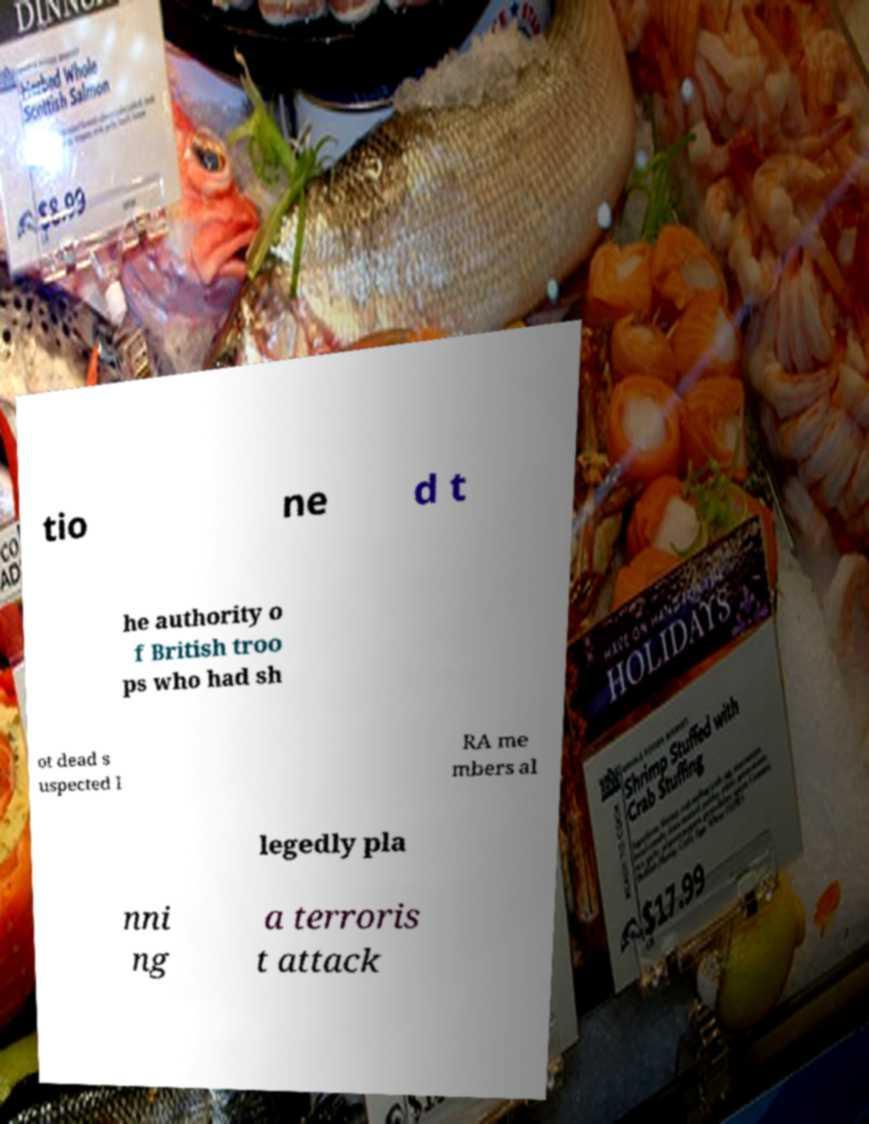I need the written content from this picture converted into text. Can you do that? tio ne d t he authority o f British troo ps who had sh ot dead s uspected I RA me mbers al legedly pla nni ng a terroris t attack 